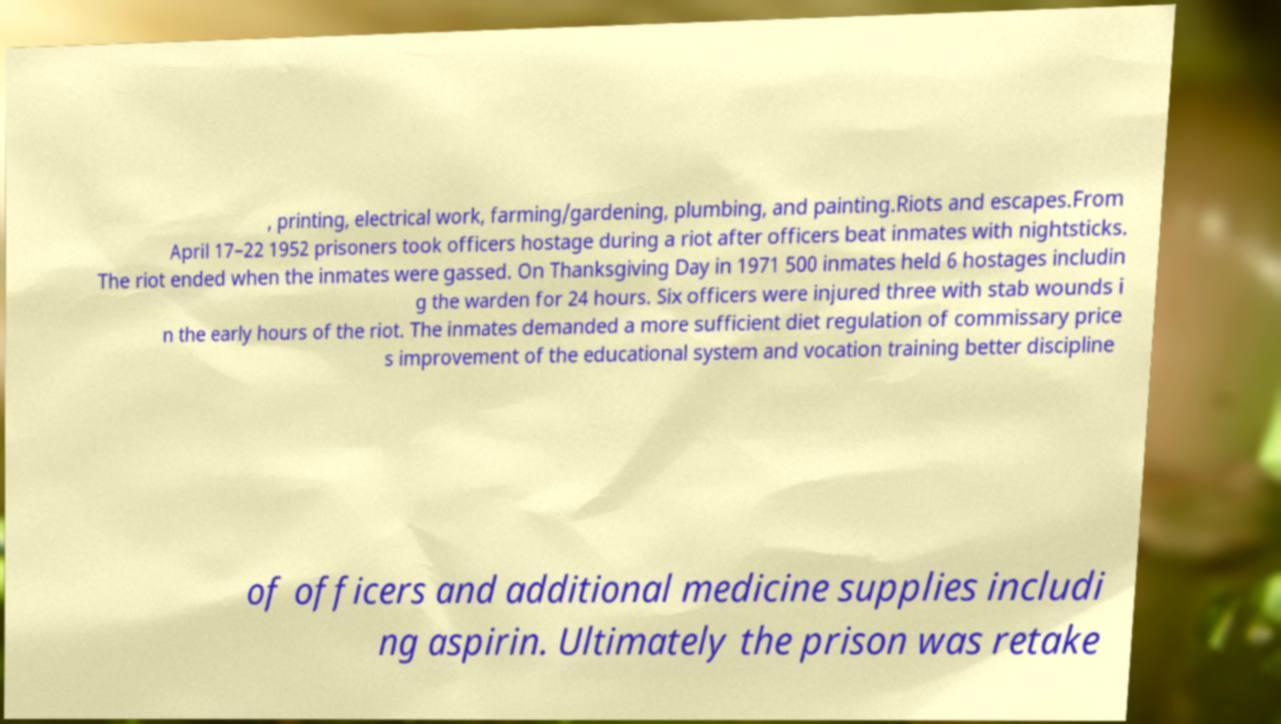Please identify and transcribe the text found in this image. , printing, electrical work, farming/gardening, plumbing, and painting.Riots and escapes.From April 17–22 1952 prisoners took officers hostage during a riot after officers beat inmates with nightsticks. The riot ended when the inmates were gassed. On Thanksgiving Day in 1971 500 inmates held 6 hostages includin g the warden for 24 hours. Six officers were injured three with stab wounds i n the early hours of the riot. The inmates demanded a more sufficient diet regulation of commissary price s improvement of the educational system and vocation training better discipline of officers and additional medicine supplies includi ng aspirin. Ultimately the prison was retake 